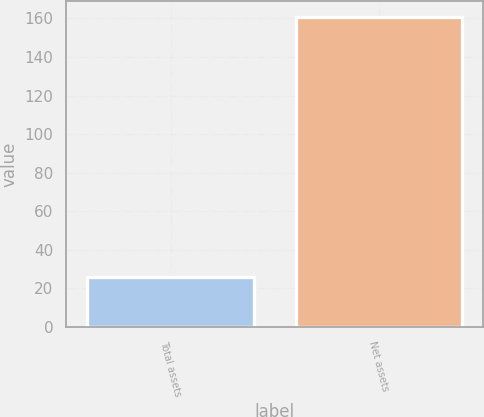<chart> <loc_0><loc_0><loc_500><loc_500><bar_chart><fcel>Total assets<fcel>Net assets<nl><fcel>26<fcel>161<nl></chart> 